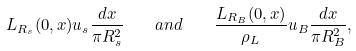Convert formula to latex. <formula><loc_0><loc_0><loc_500><loc_500>L _ { R _ { s } } ( 0 , x ) u _ { s } \frac { d x } { \pi R _ { s } ^ { 2 } } \quad a n d \quad \frac { L _ { R _ { B } } ( 0 , x ) } { \rho _ { L } } u _ { B } \frac { d x } { \pi R _ { B } ^ { 2 } } ,</formula> 